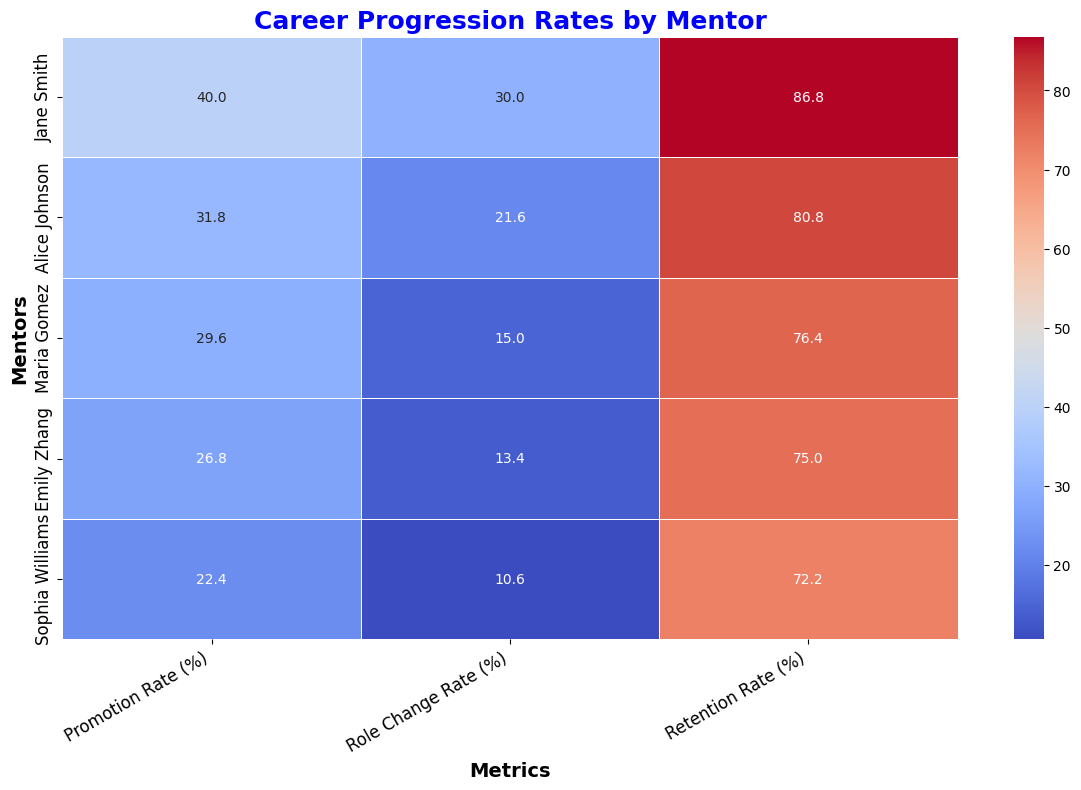What's the average promotion rate (%) for Maria Gomez's mentees? From the heatmap, find the promotion rate values for Maria Gomez across the years and calculate the average. The values are 20, 25, 30, 35, and 38. Add these values together (20 + 25 + 30 + 35 + 38 = 148) and then divide by the number of years (148 / 5).
Answer: 29.6 Which mentor has the highest retention rate (%) on average? Look at the retention rate (%) values for each mentor in the heatmap. Compare the average retention rates. Jane Smith has an average retention rate of 86.8%, which is higher than the others.
Answer: Jane Smith Who has a higher average role change rate (%) between Alice Johnson and Sophia Williams? From the heatmap, Alice Johnson’s role change rate values are 15, 18, 22, 25, and 28. Calculate the average (15 + 18 + 22 + 25 + 28 = 108, 108 / 5 = 21.6). Sophia Williams’s values are 7, 8, 10, 13, and 15. Calculate the average (7 + 8 + 10 + 13 + 15 = 53, 53 / 5 = 10.6). Compare the two averages.
Answer: Alice Johnson Between 2020 and 2021, which mentor saw the largest increase in Promotion Rate (%)? Look at the promotion rate values for 2020 and 2021 for each mentor in the heatmap. Jane Smith: from 40 to 45 (change of 5), Alice Johnson: from 32 to 36 (change of 4), Maria Gomez: from 30 to 35 (change of 5), Emily Zhang: from 27 to 32 (change of 5), Sophia Williams: from 22 to 27 (change of 5). Jane Smith has the largest increase.
Answer: Jane Smith What is the total number of mentees for Jane Smith over all years presented? Sum the number of female mentees for Jane Smith across all the years 2018-2022. The values are 10, 12, 14, 16, and 18. Add them together (10 + 12 + 14 + 16 + 18).
Answer: 70 Which metric shows the highest average value for Emily Zhang's mentees? Compare the average values for each metric (Promotion Rate, Role Change Rate, Retention Rate) for Emily Zhang. Calculate each average: Promotion Rate (18+22+27+32+35)/5 = 26.8, Role Change Rate (8+10+13+17+19)/5 = 13.4, Retention Rate (68+72+75+78+82)/5 = 75. Calculate and compare these values.
Answer: Retention Rate Which mentor had the lowest promotion rate (%) in 2018? Look at the heatmap for the promotion rate values for 2018. Compare the values for all mentors. Emily Zhang had the lowest promotion rate of 18%.
Answer: Emily Zhang What is the difference in average role change rate (%) between Maria Gomez and Emily Zhang? Calculate the average role change rate for Maria Gomez (10, 12, 15, 18, 20) = 75/5 = 15. For Emily Zhang (8, 10, 13, 17, 19) = 67/5 = 13.4. Subtract the averages (15 - 13.4).
Answer: 1.6 Which metric does the heatmap use a white color to represent a low value? Identify the lowest values represented in the heatmap and relate them to their corresponding color. White color can be seen representing low values, like Sophia Williams’s Promotion Rate (15) and Role Change Rate (7).
Answer: Promotion and Role Change Rates Among all metrics across mentors, which one indicates the highest visual contrast between the lowest and highest values? Look at the heatmap and identify the metric with the greatest variation in color tone from the lowest to the highest value. Role Change Rate shows the highest visual contrast from 7 (very light) to 40 (darker color) comparing to other metrics.
Answer: Role Change Rate 